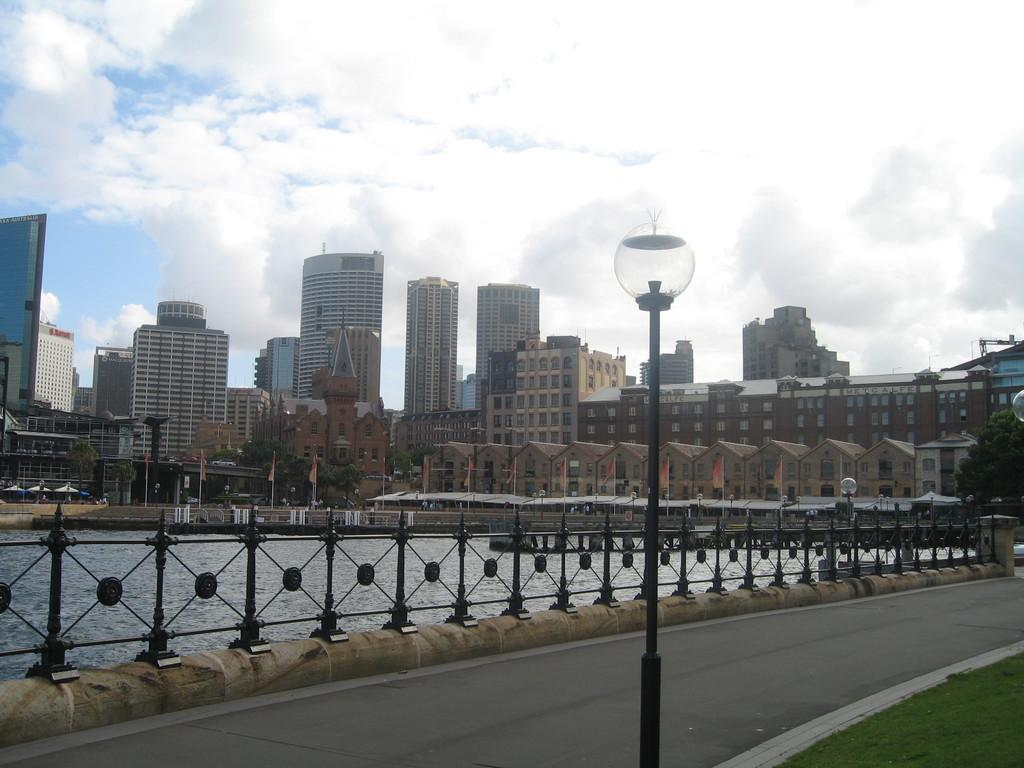What is the main feature of the image? There is a road in the image. What can be seen on the road? There is a pole on the road. What is located beside the road? There is a railing beside the road. What is beside the railing? There is a lake beside the railing. What can be seen in the background of the image? There are buildings and the sky visible in the background of the image. What type of government is depicted in the image? There is no depiction of a government in the image; it features a road, pole, railing, lake, buildings, and sky. How many cattle can be seen grazing in the image? There are no cattle present in the image. 